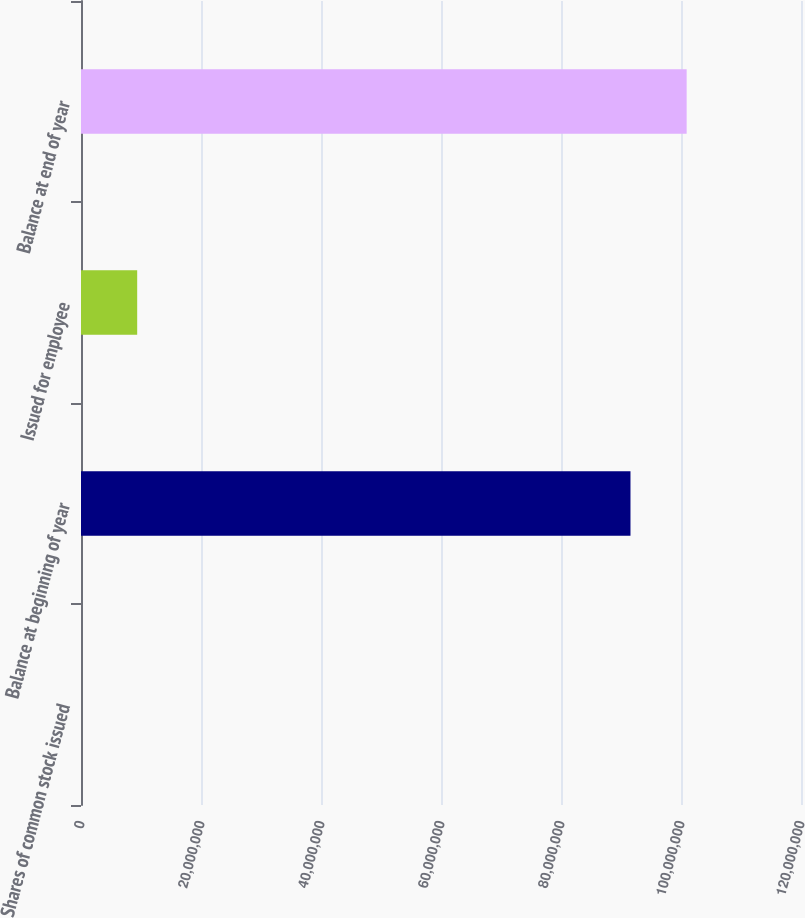Convert chart. <chart><loc_0><loc_0><loc_500><loc_500><bar_chart><fcel>Shares of common stock issued<fcel>Balance at beginning of year<fcel>Issued for employee<fcel>Balance at end of year<nl><fcel>2007<fcel>9.15794e+07<fcel>9.36484e+06<fcel>1.00942e+08<nl></chart> 